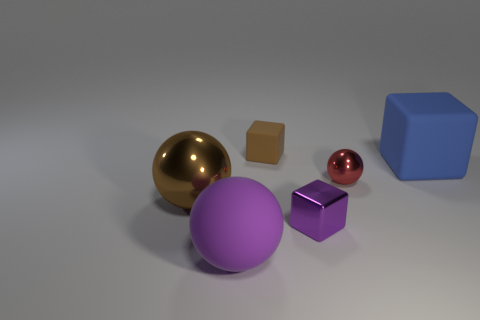Subtract all big balls. How many balls are left? 1 Subtract all blue blocks. How many blocks are left? 2 Add 2 purple spheres. How many objects exist? 8 Subtract 1 balls. How many balls are left? 2 Subtract all brown blocks. Subtract all purple spheres. How many blocks are left? 2 Add 2 matte blocks. How many matte blocks are left? 4 Add 4 large spheres. How many large spheres exist? 6 Subtract 1 red spheres. How many objects are left? 5 Subtract all brown balls. How many gray cubes are left? 0 Subtract all purple spheres. Subtract all small matte things. How many objects are left? 4 